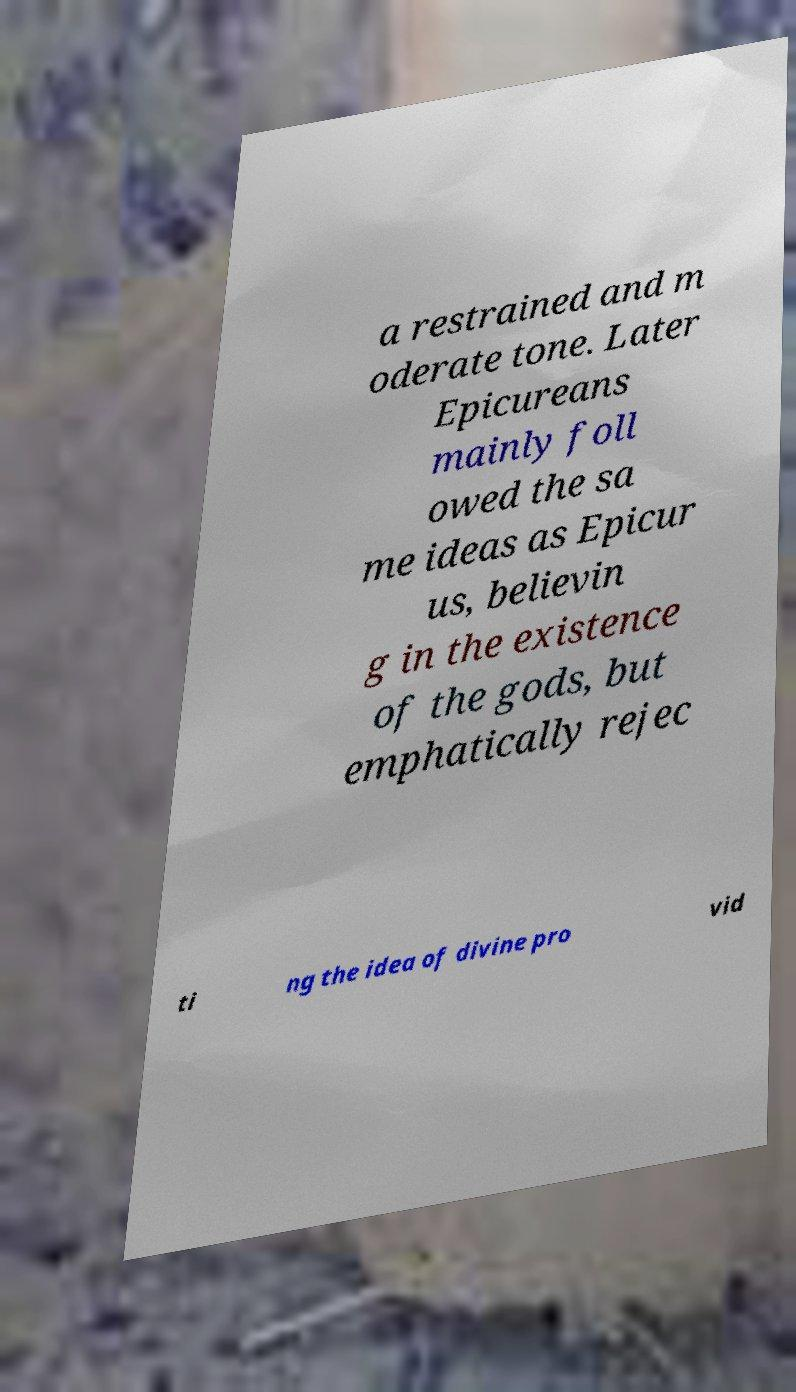For documentation purposes, I need the text within this image transcribed. Could you provide that? a restrained and m oderate tone. Later Epicureans mainly foll owed the sa me ideas as Epicur us, believin g in the existence of the gods, but emphatically rejec ti ng the idea of divine pro vid 